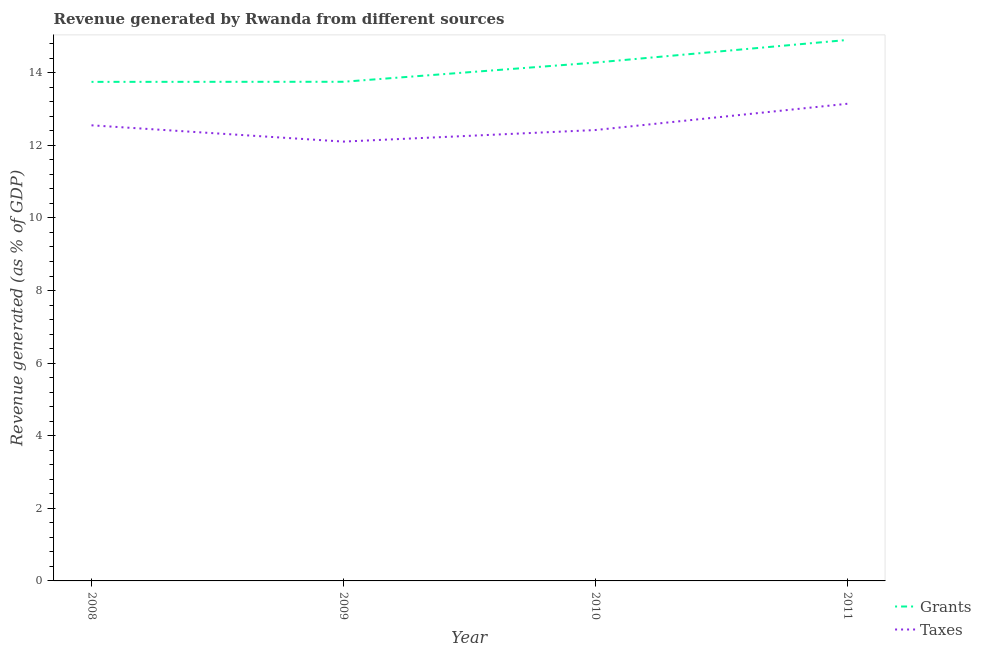How many different coloured lines are there?
Make the answer very short. 2. What is the revenue generated by grants in 2010?
Keep it short and to the point. 14.28. Across all years, what is the maximum revenue generated by taxes?
Your answer should be compact. 13.15. Across all years, what is the minimum revenue generated by grants?
Offer a very short reply. 13.75. In which year was the revenue generated by taxes minimum?
Provide a short and direct response. 2009. What is the total revenue generated by grants in the graph?
Your answer should be very brief. 56.69. What is the difference between the revenue generated by grants in 2009 and that in 2010?
Give a very brief answer. -0.53. What is the difference between the revenue generated by taxes in 2010 and the revenue generated by grants in 2008?
Offer a very short reply. -1.33. What is the average revenue generated by taxes per year?
Give a very brief answer. 12.56. In the year 2011, what is the difference between the revenue generated by grants and revenue generated by taxes?
Provide a short and direct response. 1.76. In how many years, is the revenue generated by taxes greater than 8.8 %?
Offer a terse response. 4. What is the ratio of the revenue generated by grants in 2010 to that in 2011?
Give a very brief answer. 0.96. Is the revenue generated by grants in 2008 less than that in 2009?
Provide a succinct answer. Yes. What is the difference between the highest and the second highest revenue generated by taxes?
Provide a short and direct response. 0.59. What is the difference between the highest and the lowest revenue generated by taxes?
Keep it short and to the point. 1.04. In how many years, is the revenue generated by taxes greater than the average revenue generated by taxes taken over all years?
Your answer should be very brief. 1. Is the sum of the revenue generated by taxes in 2009 and 2011 greater than the maximum revenue generated by grants across all years?
Keep it short and to the point. Yes. Is the revenue generated by taxes strictly greater than the revenue generated by grants over the years?
Your answer should be very brief. No. Is the revenue generated by taxes strictly less than the revenue generated by grants over the years?
Offer a very short reply. Yes. Are the values on the major ticks of Y-axis written in scientific E-notation?
Your response must be concise. No. Does the graph contain grids?
Make the answer very short. No. How many legend labels are there?
Provide a short and direct response. 2. What is the title of the graph?
Make the answer very short. Revenue generated by Rwanda from different sources. Does "Young" appear as one of the legend labels in the graph?
Your answer should be very brief. No. What is the label or title of the X-axis?
Your answer should be very brief. Year. What is the label or title of the Y-axis?
Make the answer very short. Revenue generated (as % of GDP). What is the Revenue generated (as % of GDP) of Grants in 2008?
Provide a succinct answer. 13.75. What is the Revenue generated (as % of GDP) of Taxes in 2008?
Give a very brief answer. 12.55. What is the Revenue generated (as % of GDP) in Grants in 2009?
Your answer should be compact. 13.75. What is the Revenue generated (as % of GDP) in Taxes in 2009?
Give a very brief answer. 12.1. What is the Revenue generated (as % of GDP) in Grants in 2010?
Ensure brevity in your answer.  14.28. What is the Revenue generated (as % of GDP) of Taxes in 2010?
Your answer should be compact. 12.42. What is the Revenue generated (as % of GDP) of Grants in 2011?
Keep it short and to the point. 14.9. What is the Revenue generated (as % of GDP) in Taxes in 2011?
Keep it short and to the point. 13.15. Across all years, what is the maximum Revenue generated (as % of GDP) of Grants?
Provide a short and direct response. 14.9. Across all years, what is the maximum Revenue generated (as % of GDP) of Taxes?
Make the answer very short. 13.15. Across all years, what is the minimum Revenue generated (as % of GDP) of Grants?
Offer a terse response. 13.75. Across all years, what is the minimum Revenue generated (as % of GDP) in Taxes?
Your answer should be very brief. 12.1. What is the total Revenue generated (as % of GDP) of Grants in the graph?
Keep it short and to the point. 56.69. What is the total Revenue generated (as % of GDP) in Taxes in the graph?
Provide a succinct answer. 50.22. What is the difference between the Revenue generated (as % of GDP) of Grants in 2008 and that in 2009?
Offer a very short reply. -0. What is the difference between the Revenue generated (as % of GDP) of Taxes in 2008 and that in 2009?
Provide a short and direct response. 0.45. What is the difference between the Revenue generated (as % of GDP) in Grants in 2008 and that in 2010?
Keep it short and to the point. -0.53. What is the difference between the Revenue generated (as % of GDP) of Taxes in 2008 and that in 2010?
Your answer should be compact. 0.13. What is the difference between the Revenue generated (as % of GDP) in Grants in 2008 and that in 2011?
Ensure brevity in your answer.  -1.15. What is the difference between the Revenue generated (as % of GDP) of Taxes in 2008 and that in 2011?
Your answer should be compact. -0.59. What is the difference between the Revenue generated (as % of GDP) of Grants in 2009 and that in 2010?
Offer a terse response. -0.53. What is the difference between the Revenue generated (as % of GDP) in Taxes in 2009 and that in 2010?
Provide a succinct answer. -0.32. What is the difference between the Revenue generated (as % of GDP) in Grants in 2009 and that in 2011?
Provide a succinct answer. -1.15. What is the difference between the Revenue generated (as % of GDP) in Taxes in 2009 and that in 2011?
Make the answer very short. -1.04. What is the difference between the Revenue generated (as % of GDP) in Grants in 2010 and that in 2011?
Make the answer very short. -0.62. What is the difference between the Revenue generated (as % of GDP) of Taxes in 2010 and that in 2011?
Ensure brevity in your answer.  -0.72. What is the difference between the Revenue generated (as % of GDP) in Grants in 2008 and the Revenue generated (as % of GDP) in Taxes in 2009?
Your response must be concise. 1.65. What is the difference between the Revenue generated (as % of GDP) in Grants in 2008 and the Revenue generated (as % of GDP) in Taxes in 2010?
Give a very brief answer. 1.33. What is the difference between the Revenue generated (as % of GDP) in Grants in 2008 and the Revenue generated (as % of GDP) in Taxes in 2011?
Keep it short and to the point. 0.6. What is the difference between the Revenue generated (as % of GDP) in Grants in 2009 and the Revenue generated (as % of GDP) in Taxes in 2010?
Your response must be concise. 1.33. What is the difference between the Revenue generated (as % of GDP) of Grants in 2009 and the Revenue generated (as % of GDP) of Taxes in 2011?
Offer a very short reply. 0.61. What is the difference between the Revenue generated (as % of GDP) of Grants in 2010 and the Revenue generated (as % of GDP) of Taxes in 2011?
Offer a very short reply. 1.14. What is the average Revenue generated (as % of GDP) of Grants per year?
Ensure brevity in your answer.  14.17. What is the average Revenue generated (as % of GDP) in Taxes per year?
Offer a very short reply. 12.56. In the year 2008, what is the difference between the Revenue generated (as % of GDP) in Grants and Revenue generated (as % of GDP) in Taxes?
Offer a very short reply. 1.2. In the year 2009, what is the difference between the Revenue generated (as % of GDP) of Grants and Revenue generated (as % of GDP) of Taxes?
Your answer should be compact. 1.65. In the year 2010, what is the difference between the Revenue generated (as % of GDP) in Grants and Revenue generated (as % of GDP) in Taxes?
Offer a very short reply. 1.86. In the year 2011, what is the difference between the Revenue generated (as % of GDP) of Grants and Revenue generated (as % of GDP) of Taxes?
Make the answer very short. 1.76. What is the ratio of the Revenue generated (as % of GDP) in Grants in 2008 to that in 2009?
Your answer should be very brief. 1. What is the ratio of the Revenue generated (as % of GDP) of Taxes in 2008 to that in 2009?
Your response must be concise. 1.04. What is the ratio of the Revenue generated (as % of GDP) in Grants in 2008 to that in 2010?
Give a very brief answer. 0.96. What is the ratio of the Revenue generated (as % of GDP) in Taxes in 2008 to that in 2010?
Your response must be concise. 1.01. What is the ratio of the Revenue generated (as % of GDP) of Grants in 2008 to that in 2011?
Offer a terse response. 0.92. What is the ratio of the Revenue generated (as % of GDP) of Taxes in 2008 to that in 2011?
Keep it short and to the point. 0.95. What is the ratio of the Revenue generated (as % of GDP) in Grants in 2009 to that in 2010?
Provide a short and direct response. 0.96. What is the ratio of the Revenue generated (as % of GDP) of Taxes in 2009 to that in 2010?
Keep it short and to the point. 0.97. What is the ratio of the Revenue generated (as % of GDP) in Grants in 2009 to that in 2011?
Make the answer very short. 0.92. What is the ratio of the Revenue generated (as % of GDP) of Taxes in 2009 to that in 2011?
Make the answer very short. 0.92. What is the ratio of the Revenue generated (as % of GDP) of Grants in 2010 to that in 2011?
Ensure brevity in your answer.  0.96. What is the ratio of the Revenue generated (as % of GDP) of Taxes in 2010 to that in 2011?
Your answer should be compact. 0.94. What is the difference between the highest and the second highest Revenue generated (as % of GDP) of Grants?
Your answer should be compact. 0.62. What is the difference between the highest and the second highest Revenue generated (as % of GDP) in Taxes?
Keep it short and to the point. 0.59. What is the difference between the highest and the lowest Revenue generated (as % of GDP) of Grants?
Make the answer very short. 1.15. What is the difference between the highest and the lowest Revenue generated (as % of GDP) of Taxes?
Your answer should be compact. 1.04. 